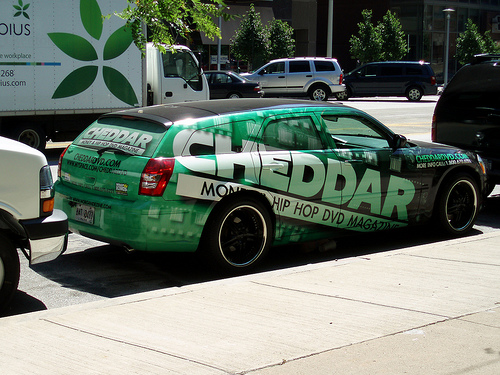<image>
Is there a car behind the truck? No. The car is not behind the truck. From this viewpoint, the car appears to be positioned elsewhere in the scene. Is there a logo on the car? Yes. Looking at the image, I can see the logo is positioned on top of the car, with the car providing support. Is there a wheel on the car? No. The wheel is not positioned on the car. They may be near each other, but the wheel is not supported by or resting on top of the car. 